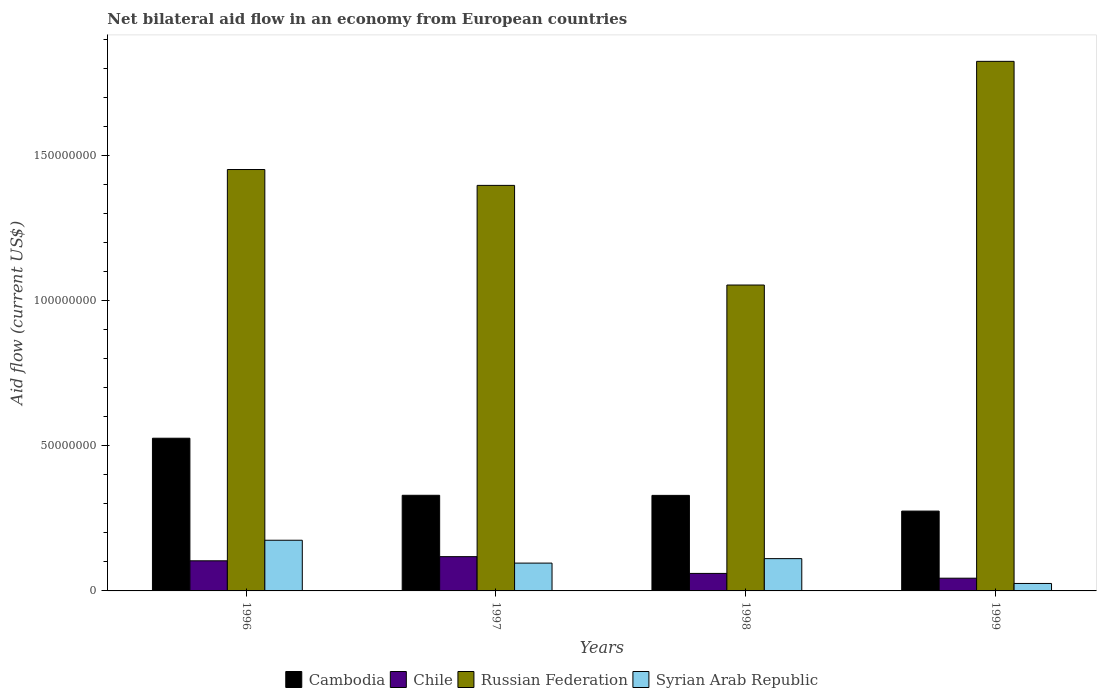Are the number of bars per tick equal to the number of legend labels?
Provide a succinct answer. Yes. Are the number of bars on each tick of the X-axis equal?
Provide a short and direct response. Yes. How many bars are there on the 3rd tick from the right?
Ensure brevity in your answer.  4. What is the label of the 4th group of bars from the left?
Provide a short and direct response. 1999. What is the net bilateral aid flow in Cambodia in 1998?
Make the answer very short. 3.29e+07. Across all years, what is the maximum net bilateral aid flow in Russian Federation?
Provide a succinct answer. 1.82e+08. Across all years, what is the minimum net bilateral aid flow in Cambodia?
Your response must be concise. 2.75e+07. In which year was the net bilateral aid flow in Syrian Arab Republic maximum?
Offer a terse response. 1996. What is the total net bilateral aid flow in Russian Federation in the graph?
Ensure brevity in your answer.  5.72e+08. What is the difference between the net bilateral aid flow in Syrian Arab Republic in 1997 and that in 1998?
Make the answer very short. -1.54e+06. What is the difference between the net bilateral aid flow in Chile in 1996 and the net bilateral aid flow in Syrian Arab Republic in 1999?
Provide a succinct answer. 7.80e+06. What is the average net bilateral aid flow in Cambodia per year?
Make the answer very short. 3.65e+07. In the year 1998, what is the difference between the net bilateral aid flow in Russian Federation and net bilateral aid flow in Cambodia?
Offer a terse response. 7.24e+07. What is the ratio of the net bilateral aid flow in Cambodia in 1996 to that in 1998?
Give a very brief answer. 1.6. Is the net bilateral aid flow in Syrian Arab Republic in 1997 less than that in 1998?
Your answer should be compact. Yes. Is the difference between the net bilateral aid flow in Russian Federation in 1996 and 1998 greater than the difference between the net bilateral aid flow in Cambodia in 1996 and 1998?
Provide a succinct answer. Yes. What is the difference between the highest and the second highest net bilateral aid flow in Russian Federation?
Make the answer very short. 3.72e+07. What is the difference between the highest and the lowest net bilateral aid flow in Cambodia?
Keep it short and to the point. 2.51e+07. Is it the case that in every year, the sum of the net bilateral aid flow in Syrian Arab Republic and net bilateral aid flow in Chile is greater than the sum of net bilateral aid flow in Russian Federation and net bilateral aid flow in Cambodia?
Offer a very short reply. No. What does the 3rd bar from the left in 1997 represents?
Give a very brief answer. Russian Federation. What does the 2nd bar from the right in 1996 represents?
Offer a terse response. Russian Federation. How many bars are there?
Your answer should be compact. 16. Are all the bars in the graph horizontal?
Keep it short and to the point. No. How many years are there in the graph?
Keep it short and to the point. 4. Are the values on the major ticks of Y-axis written in scientific E-notation?
Provide a short and direct response. No. Does the graph contain any zero values?
Make the answer very short. No. Does the graph contain grids?
Provide a succinct answer. No. What is the title of the graph?
Make the answer very short. Net bilateral aid flow in an economy from European countries. What is the label or title of the X-axis?
Provide a succinct answer. Years. What is the Aid flow (current US$) in Cambodia in 1996?
Keep it short and to the point. 5.26e+07. What is the Aid flow (current US$) in Chile in 1996?
Your response must be concise. 1.04e+07. What is the Aid flow (current US$) of Russian Federation in 1996?
Offer a very short reply. 1.45e+08. What is the Aid flow (current US$) in Syrian Arab Republic in 1996?
Give a very brief answer. 1.74e+07. What is the Aid flow (current US$) of Cambodia in 1997?
Keep it short and to the point. 3.29e+07. What is the Aid flow (current US$) in Chile in 1997?
Your response must be concise. 1.18e+07. What is the Aid flow (current US$) in Russian Federation in 1997?
Offer a very short reply. 1.40e+08. What is the Aid flow (current US$) of Syrian Arab Republic in 1997?
Your response must be concise. 9.58e+06. What is the Aid flow (current US$) of Cambodia in 1998?
Make the answer very short. 3.29e+07. What is the Aid flow (current US$) in Chile in 1998?
Offer a terse response. 6.03e+06. What is the Aid flow (current US$) of Russian Federation in 1998?
Provide a short and direct response. 1.05e+08. What is the Aid flow (current US$) in Syrian Arab Republic in 1998?
Your response must be concise. 1.11e+07. What is the Aid flow (current US$) in Cambodia in 1999?
Your response must be concise. 2.75e+07. What is the Aid flow (current US$) of Chile in 1999?
Your response must be concise. 4.38e+06. What is the Aid flow (current US$) of Russian Federation in 1999?
Your answer should be very brief. 1.82e+08. What is the Aid flow (current US$) of Syrian Arab Republic in 1999?
Keep it short and to the point. 2.57e+06. Across all years, what is the maximum Aid flow (current US$) in Cambodia?
Your answer should be very brief. 5.26e+07. Across all years, what is the maximum Aid flow (current US$) in Chile?
Your response must be concise. 1.18e+07. Across all years, what is the maximum Aid flow (current US$) in Russian Federation?
Your answer should be compact. 1.82e+08. Across all years, what is the maximum Aid flow (current US$) in Syrian Arab Republic?
Offer a very short reply. 1.74e+07. Across all years, what is the minimum Aid flow (current US$) in Cambodia?
Provide a succinct answer. 2.75e+07. Across all years, what is the minimum Aid flow (current US$) in Chile?
Your answer should be compact. 4.38e+06. Across all years, what is the minimum Aid flow (current US$) of Russian Federation?
Provide a succinct answer. 1.05e+08. Across all years, what is the minimum Aid flow (current US$) of Syrian Arab Republic?
Offer a very short reply. 2.57e+06. What is the total Aid flow (current US$) in Cambodia in the graph?
Ensure brevity in your answer.  1.46e+08. What is the total Aid flow (current US$) of Chile in the graph?
Provide a short and direct response. 3.26e+07. What is the total Aid flow (current US$) in Russian Federation in the graph?
Make the answer very short. 5.72e+08. What is the total Aid flow (current US$) of Syrian Arab Republic in the graph?
Offer a terse response. 4.07e+07. What is the difference between the Aid flow (current US$) of Cambodia in 1996 and that in 1997?
Your answer should be very brief. 1.96e+07. What is the difference between the Aid flow (current US$) in Chile in 1996 and that in 1997?
Provide a short and direct response. -1.43e+06. What is the difference between the Aid flow (current US$) in Russian Federation in 1996 and that in 1997?
Make the answer very short. 5.46e+06. What is the difference between the Aid flow (current US$) in Syrian Arab Republic in 1996 and that in 1997?
Your answer should be very brief. 7.87e+06. What is the difference between the Aid flow (current US$) of Cambodia in 1996 and that in 1998?
Offer a terse response. 1.97e+07. What is the difference between the Aid flow (current US$) in Chile in 1996 and that in 1998?
Give a very brief answer. 4.34e+06. What is the difference between the Aid flow (current US$) of Russian Federation in 1996 and that in 1998?
Provide a succinct answer. 3.98e+07. What is the difference between the Aid flow (current US$) in Syrian Arab Republic in 1996 and that in 1998?
Provide a succinct answer. 6.33e+06. What is the difference between the Aid flow (current US$) in Cambodia in 1996 and that in 1999?
Provide a short and direct response. 2.51e+07. What is the difference between the Aid flow (current US$) of Chile in 1996 and that in 1999?
Make the answer very short. 5.99e+06. What is the difference between the Aid flow (current US$) of Russian Federation in 1996 and that in 1999?
Make the answer very short. -3.72e+07. What is the difference between the Aid flow (current US$) of Syrian Arab Republic in 1996 and that in 1999?
Offer a very short reply. 1.49e+07. What is the difference between the Aid flow (current US$) of Cambodia in 1997 and that in 1998?
Ensure brevity in your answer.  3.00e+04. What is the difference between the Aid flow (current US$) in Chile in 1997 and that in 1998?
Provide a succinct answer. 5.77e+06. What is the difference between the Aid flow (current US$) in Russian Federation in 1997 and that in 1998?
Your answer should be compact. 3.43e+07. What is the difference between the Aid flow (current US$) in Syrian Arab Republic in 1997 and that in 1998?
Offer a very short reply. -1.54e+06. What is the difference between the Aid flow (current US$) of Cambodia in 1997 and that in 1999?
Your answer should be compact. 5.44e+06. What is the difference between the Aid flow (current US$) in Chile in 1997 and that in 1999?
Offer a very short reply. 7.42e+06. What is the difference between the Aid flow (current US$) of Russian Federation in 1997 and that in 1999?
Give a very brief answer. -4.27e+07. What is the difference between the Aid flow (current US$) of Syrian Arab Republic in 1997 and that in 1999?
Give a very brief answer. 7.01e+06. What is the difference between the Aid flow (current US$) in Cambodia in 1998 and that in 1999?
Ensure brevity in your answer.  5.41e+06. What is the difference between the Aid flow (current US$) in Chile in 1998 and that in 1999?
Give a very brief answer. 1.65e+06. What is the difference between the Aid flow (current US$) of Russian Federation in 1998 and that in 1999?
Make the answer very short. -7.70e+07. What is the difference between the Aid flow (current US$) of Syrian Arab Republic in 1998 and that in 1999?
Offer a terse response. 8.55e+06. What is the difference between the Aid flow (current US$) of Cambodia in 1996 and the Aid flow (current US$) of Chile in 1997?
Your response must be concise. 4.08e+07. What is the difference between the Aid flow (current US$) of Cambodia in 1996 and the Aid flow (current US$) of Russian Federation in 1997?
Make the answer very short. -8.71e+07. What is the difference between the Aid flow (current US$) of Cambodia in 1996 and the Aid flow (current US$) of Syrian Arab Republic in 1997?
Provide a succinct answer. 4.30e+07. What is the difference between the Aid flow (current US$) in Chile in 1996 and the Aid flow (current US$) in Russian Federation in 1997?
Keep it short and to the point. -1.29e+08. What is the difference between the Aid flow (current US$) of Chile in 1996 and the Aid flow (current US$) of Syrian Arab Republic in 1997?
Your response must be concise. 7.90e+05. What is the difference between the Aid flow (current US$) of Russian Federation in 1996 and the Aid flow (current US$) of Syrian Arab Republic in 1997?
Provide a short and direct response. 1.36e+08. What is the difference between the Aid flow (current US$) in Cambodia in 1996 and the Aid flow (current US$) in Chile in 1998?
Give a very brief answer. 4.66e+07. What is the difference between the Aid flow (current US$) in Cambodia in 1996 and the Aid flow (current US$) in Russian Federation in 1998?
Provide a short and direct response. -5.28e+07. What is the difference between the Aid flow (current US$) in Cambodia in 1996 and the Aid flow (current US$) in Syrian Arab Republic in 1998?
Give a very brief answer. 4.15e+07. What is the difference between the Aid flow (current US$) of Chile in 1996 and the Aid flow (current US$) of Russian Federation in 1998?
Your answer should be very brief. -9.50e+07. What is the difference between the Aid flow (current US$) in Chile in 1996 and the Aid flow (current US$) in Syrian Arab Republic in 1998?
Ensure brevity in your answer.  -7.50e+05. What is the difference between the Aid flow (current US$) of Russian Federation in 1996 and the Aid flow (current US$) of Syrian Arab Republic in 1998?
Offer a very short reply. 1.34e+08. What is the difference between the Aid flow (current US$) in Cambodia in 1996 and the Aid flow (current US$) in Chile in 1999?
Ensure brevity in your answer.  4.82e+07. What is the difference between the Aid flow (current US$) in Cambodia in 1996 and the Aid flow (current US$) in Russian Federation in 1999?
Make the answer very short. -1.30e+08. What is the difference between the Aid flow (current US$) in Cambodia in 1996 and the Aid flow (current US$) in Syrian Arab Republic in 1999?
Offer a very short reply. 5.00e+07. What is the difference between the Aid flow (current US$) in Chile in 1996 and the Aid flow (current US$) in Russian Federation in 1999?
Keep it short and to the point. -1.72e+08. What is the difference between the Aid flow (current US$) of Chile in 1996 and the Aid flow (current US$) of Syrian Arab Republic in 1999?
Make the answer very short. 7.80e+06. What is the difference between the Aid flow (current US$) in Russian Federation in 1996 and the Aid flow (current US$) in Syrian Arab Republic in 1999?
Offer a terse response. 1.43e+08. What is the difference between the Aid flow (current US$) in Cambodia in 1997 and the Aid flow (current US$) in Chile in 1998?
Offer a terse response. 2.69e+07. What is the difference between the Aid flow (current US$) of Cambodia in 1997 and the Aid flow (current US$) of Russian Federation in 1998?
Make the answer very short. -7.24e+07. What is the difference between the Aid flow (current US$) of Cambodia in 1997 and the Aid flow (current US$) of Syrian Arab Republic in 1998?
Make the answer very short. 2.18e+07. What is the difference between the Aid flow (current US$) of Chile in 1997 and the Aid flow (current US$) of Russian Federation in 1998?
Give a very brief answer. -9.35e+07. What is the difference between the Aid flow (current US$) in Chile in 1997 and the Aid flow (current US$) in Syrian Arab Republic in 1998?
Provide a short and direct response. 6.80e+05. What is the difference between the Aid flow (current US$) of Russian Federation in 1997 and the Aid flow (current US$) of Syrian Arab Republic in 1998?
Give a very brief answer. 1.29e+08. What is the difference between the Aid flow (current US$) of Cambodia in 1997 and the Aid flow (current US$) of Chile in 1999?
Provide a succinct answer. 2.86e+07. What is the difference between the Aid flow (current US$) in Cambodia in 1997 and the Aid flow (current US$) in Russian Federation in 1999?
Ensure brevity in your answer.  -1.49e+08. What is the difference between the Aid flow (current US$) of Cambodia in 1997 and the Aid flow (current US$) of Syrian Arab Republic in 1999?
Your answer should be very brief. 3.04e+07. What is the difference between the Aid flow (current US$) in Chile in 1997 and the Aid flow (current US$) in Russian Federation in 1999?
Offer a very short reply. -1.71e+08. What is the difference between the Aid flow (current US$) of Chile in 1997 and the Aid flow (current US$) of Syrian Arab Republic in 1999?
Provide a succinct answer. 9.23e+06. What is the difference between the Aid flow (current US$) of Russian Federation in 1997 and the Aid flow (current US$) of Syrian Arab Republic in 1999?
Ensure brevity in your answer.  1.37e+08. What is the difference between the Aid flow (current US$) of Cambodia in 1998 and the Aid flow (current US$) of Chile in 1999?
Provide a succinct answer. 2.85e+07. What is the difference between the Aid flow (current US$) in Cambodia in 1998 and the Aid flow (current US$) in Russian Federation in 1999?
Ensure brevity in your answer.  -1.49e+08. What is the difference between the Aid flow (current US$) of Cambodia in 1998 and the Aid flow (current US$) of Syrian Arab Republic in 1999?
Make the answer very short. 3.03e+07. What is the difference between the Aid flow (current US$) in Chile in 1998 and the Aid flow (current US$) in Russian Federation in 1999?
Your response must be concise. -1.76e+08. What is the difference between the Aid flow (current US$) of Chile in 1998 and the Aid flow (current US$) of Syrian Arab Republic in 1999?
Offer a terse response. 3.46e+06. What is the difference between the Aid flow (current US$) in Russian Federation in 1998 and the Aid flow (current US$) in Syrian Arab Republic in 1999?
Your answer should be very brief. 1.03e+08. What is the average Aid flow (current US$) in Cambodia per year?
Ensure brevity in your answer.  3.65e+07. What is the average Aid flow (current US$) of Chile per year?
Give a very brief answer. 8.14e+06. What is the average Aid flow (current US$) in Russian Federation per year?
Offer a terse response. 1.43e+08. What is the average Aid flow (current US$) of Syrian Arab Republic per year?
Give a very brief answer. 1.02e+07. In the year 1996, what is the difference between the Aid flow (current US$) of Cambodia and Aid flow (current US$) of Chile?
Ensure brevity in your answer.  4.22e+07. In the year 1996, what is the difference between the Aid flow (current US$) of Cambodia and Aid flow (current US$) of Russian Federation?
Offer a very short reply. -9.25e+07. In the year 1996, what is the difference between the Aid flow (current US$) of Cambodia and Aid flow (current US$) of Syrian Arab Republic?
Give a very brief answer. 3.51e+07. In the year 1996, what is the difference between the Aid flow (current US$) of Chile and Aid flow (current US$) of Russian Federation?
Provide a short and direct response. -1.35e+08. In the year 1996, what is the difference between the Aid flow (current US$) of Chile and Aid flow (current US$) of Syrian Arab Republic?
Ensure brevity in your answer.  -7.08e+06. In the year 1996, what is the difference between the Aid flow (current US$) of Russian Federation and Aid flow (current US$) of Syrian Arab Republic?
Your answer should be very brief. 1.28e+08. In the year 1997, what is the difference between the Aid flow (current US$) of Cambodia and Aid flow (current US$) of Chile?
Your answer should be compact. 2.11e+07. In the year 1997, what is the difference between the Aid flow (current US$) of Cambodia and Aid flow (current US$) of Russian Federation?
Keep it short and to the point. -1.07e+08. In the year 1997, what is the difference between the Aid flow (current US$) of Cambodia and Aid flow (current US$) of Syrian Arab Republic?
Your answer should be compact. 2.34e+07. In the year 1997, what is the difference between the Aid flow (current US$) in Chile and Aid flow (current US$) in Russian Federation?
Provide a short and direct response. -1.28e+08. In the year 1997, what is the difference between the Aid flow (current US$) of Chile and Aid flow (current US$) of Syrian Arab Republic?
Your answer should be very brief. 2.22e+06. In the year 1997, what is the difference between the Aid flow (current US$) in Russian Federation and Aid flow (current US$) in Syrian Arab Republic?
Your response must be concise. 1.30e+08. In the year 1998, what is the difference between the Aid flow (current US$) of Cambodia and Aid flow (current US$) of Chile?
Your answer should be compact. 2.69e+07. In the year 1998, what is the difference between the Aid flow (current US$) of Cambodia and Aid flow (current US$) of Russian Federation?
Provide a short and direct response. -7.24e+07. In the year 1998, what is the difference between the Aid flow (current US$) in Cambodia and Aid flow (current US$) in Syrian Arab Republic?
Your answer should be compact. 2.18e+07. In the year 1998, what is the difference between the Aid flow (current US$) in Chile and Aid flow (current US$) in Russian Federation?
Offer a very short reply. -9.93e+07. In the year 1998, what is the difference between the Aid flow (current US$) in Chile and Aid flow (current US$) in Syrian Arab Republic?
Make the answer very short. -5.09e+06. In the year 1998, what is the difference between the Aid flow (current US$) in Russian Federation and Aid flow (current US$) in Syrian Arab Republic?
Keep it short and to the point. 9.42e+07. In the year 1999, what is the difference between the Aid flow (current US$) of Cambodia and Aid flow (current US$) of Chile?
Provide a short and direct response. 2.31e+07. In the year 1999, what is the difference between the Aid flow (current US$) in Cambodia and Aid flow (current US$) in Russian Federation?
Your response must be concise. -1.55e+08. In the year 1999, what is the difference between the Aid flow (current US$) in Cambodia and Aid flow (current US$) in Syrian Arab Republic?
Your answer should be very brief. 2.49e+07. In the year 1999, what is the difference between the Aid flow (current US$) in Chile and Aid flow (current US$) in Russian Federation?
Offer a very short reply. -1.78e+08. In the year 1999, what is the difference between the Aid flow (current US$) of Chile and Aid flow (current US$) of Syrian Arab Republic?
Give a very brief answer. 1.81e+06. In the year 1999, what is the difference between the Aid flow (current US$) of Russian Federation and Aid flow (current US$) of Syrian Arab Republic?
Keep it short and to the point. 1.80e+08. What is the ratio of the Aid flow (current US$) of Cambodia in 1996 to that in 1997?
Ensure brevity in your answer.  1.6. What is the ratio of the Aid flow (current US$) in Chile in 1996 to that in 1997?
Make the answer very short. 0.88. What is the ratio of the Aid flow (current US$) of Russian Federation in 1996 to that in 1997?
Provide a short and direct response. 1.04. What is the ratio of the Aid flow (current US$) in Syrian Arab Republic in 1996 to that in 1997?
Give a very brief answer. 1.82. What is the ratio of the Aid flow (current US$) of Cambodia in 1996 to that in 1998?
Your answer should be very brief. 1.6. What is the ratio of the Aid flow (current US$) of Chile in 1996 to that in 1998?
Offer a terse response. 1.72. What is the ratio of the Aid flow (current US$) of Russian Federation in 1996 to that in 1998?
Your answer should be compact. 1.38. What is the ratio of the Aid flow (current US$) of Syrian Arab Republic in 1996 to that in 1998?
Provide a succinct answer. 1.57. What is the ratio of the Aid flow (current US$) in Cambodia in 1996 to that in 1999?
Keep it short and to the point. 1.91. What is the ratio of the Aid flow (current US$) in Chile in 1996 to that in 1999?
Offer a very short reply. 2.37. What is the ratio of the Aid flow (current US$) in Russian Federation in 1996 to that in 1999?
Keep it short and to the point. 0.8. What is the ratio of the Aid flow (current US$) of Syrian Arab Republic in 1996 to that in 1999?
Your answer should be very brief. 6.79. What is the ratio of the Aid flow (current US$) in Chile in 1997 to that in 1998?
Provide a succinct answer. 1.96. What is the ratio of the Aid flow (current US$) of Russian Federation in 1997 to that in 1998?
Offer a terse response. 1.33. What is the ratio of the Aid flow (current US$) in Syrian Arab Republic in 1997 to that in 1998?
Your response must be concise. 0.86. What is the ratio of the Aid flow (current US$) of Cambodia in 1997 to that in 1999?
Offer a very short reply. 1.2. What is the ratio of the Aid flow (current US$) in Chile in 1997 to that in 1999?
Keep it short and to the point. 2.69. What is the ratio of the Aid flow (current US$) in Russian Federation in 1997 to that in 1999?
Keep it short and to the point. 0.77. What is the ratio of the Aid flow (current US$) of Syrian Arab Republic in 1997 to that in 1999?
Make the answer very short. 3.73. What is the ratio of the Aid flow (current US$) of Cambodia in 1998 to that in 1999?
Keep it short and to the point. 1.2. What is the ratio of the Aid flow (current US$) in Chile in 1998 to that in 1999?
Offer a very short reply. 1.38. What is the ratio of the Aid flow (current US$) in Russian Federation in 1998 to that in 1999?
Provide a short and direct response. 0.58. What is the ratio of the Aid flow (current US$) in Syrian Arab Republic in 1998 to that in 1999?
Your response must be concise. 4.33. What is the difference between the highest and the second highest Aid flow (current US$) of Cambodia?
Keep it short and to the point. 1.96e+07. What is the difference between the highest and the second highest Aid flow (current US$) of Chile?
Provide a short and direct response. 1.43e+06. What is the difference between the highest and the second highest Aid flow (current US$) in Russian Federation?
Offer a terse response. 3.72e+07. What is the difference between the highest and the second highest Aid flow (current US$) in Syrian Arab Republic?
Keep it short and to the point. 6.33e+06. What is the difference between the highest and the lowest Aid flow (current US$) of Cambodia?
Provide a succinct answer. 2.51e+07. What is the difference between the highest and the lowest Aid flow (current US$) of Chile?
Your answer should be very brief. 7.42e+06. What is the difference between the highest and the lowest Aid flow (current US$) of Russian Federation?
Offer a terse response. 7.70e+07. What is the difference between the highest and the lowest Aid flow (current US$) of Syrian Arab Republic?
Your answer should be very brief. 1.49e+07. 